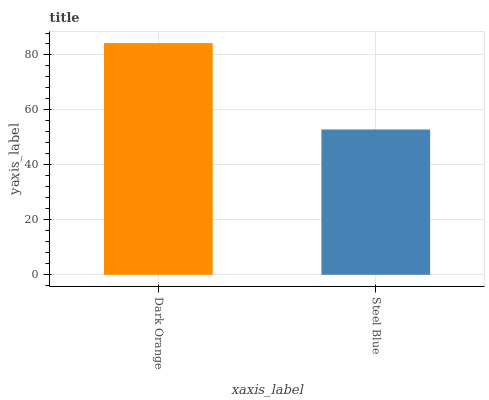Is Steel Blue the minimum?
Answer yes or no. Yes. Is Dark Orange the maximum?
Answer yes or no. Yes. Is Steel Blue the maximum?
Answer yes or no. No. Is Dark Orange greater than Steel Blue?
Answer yes or no. Yes. Is Steel Blue less than Dark Orange?
Answer yes or no. Yes. Is Steel Blue greater than Dark Orange?
Answer yes or no. No. Is Dark Orange less than Steel Blue?
Answer yes or no. No. Is Dark Orange the high median?
Answer yes or no. Yes. Is Steel Blue the low median?
Answer yes or no. Yes. Is Steel Blue the high median?
Answer yes or no. No. Is Dark Orange the low median?
Answer yes or no. No. 